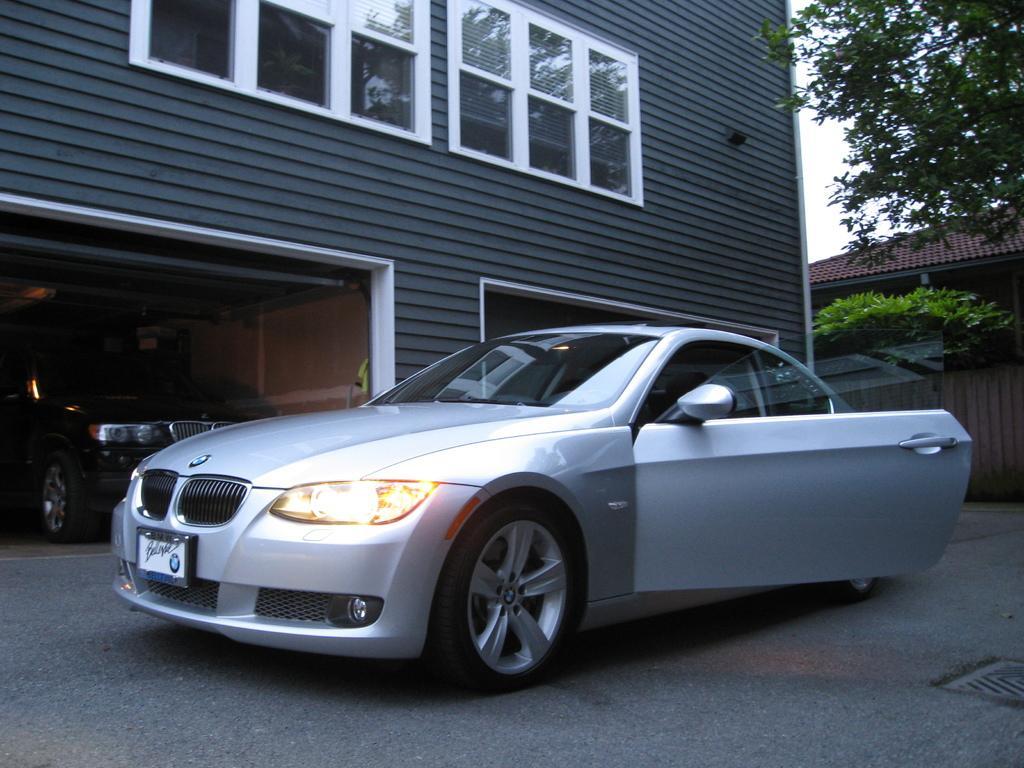Could you give a brief overview of what you see in this image? In this image we can see a car on the road. In the background of the image there are houses, trees, sky. 